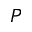<formula> <loc_0><loc_0><loc_500><loc_500>P</formula> 